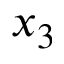<formula> <loc_0><loc_0><loc_500><loc_500>x _ { 3 }</formula> 